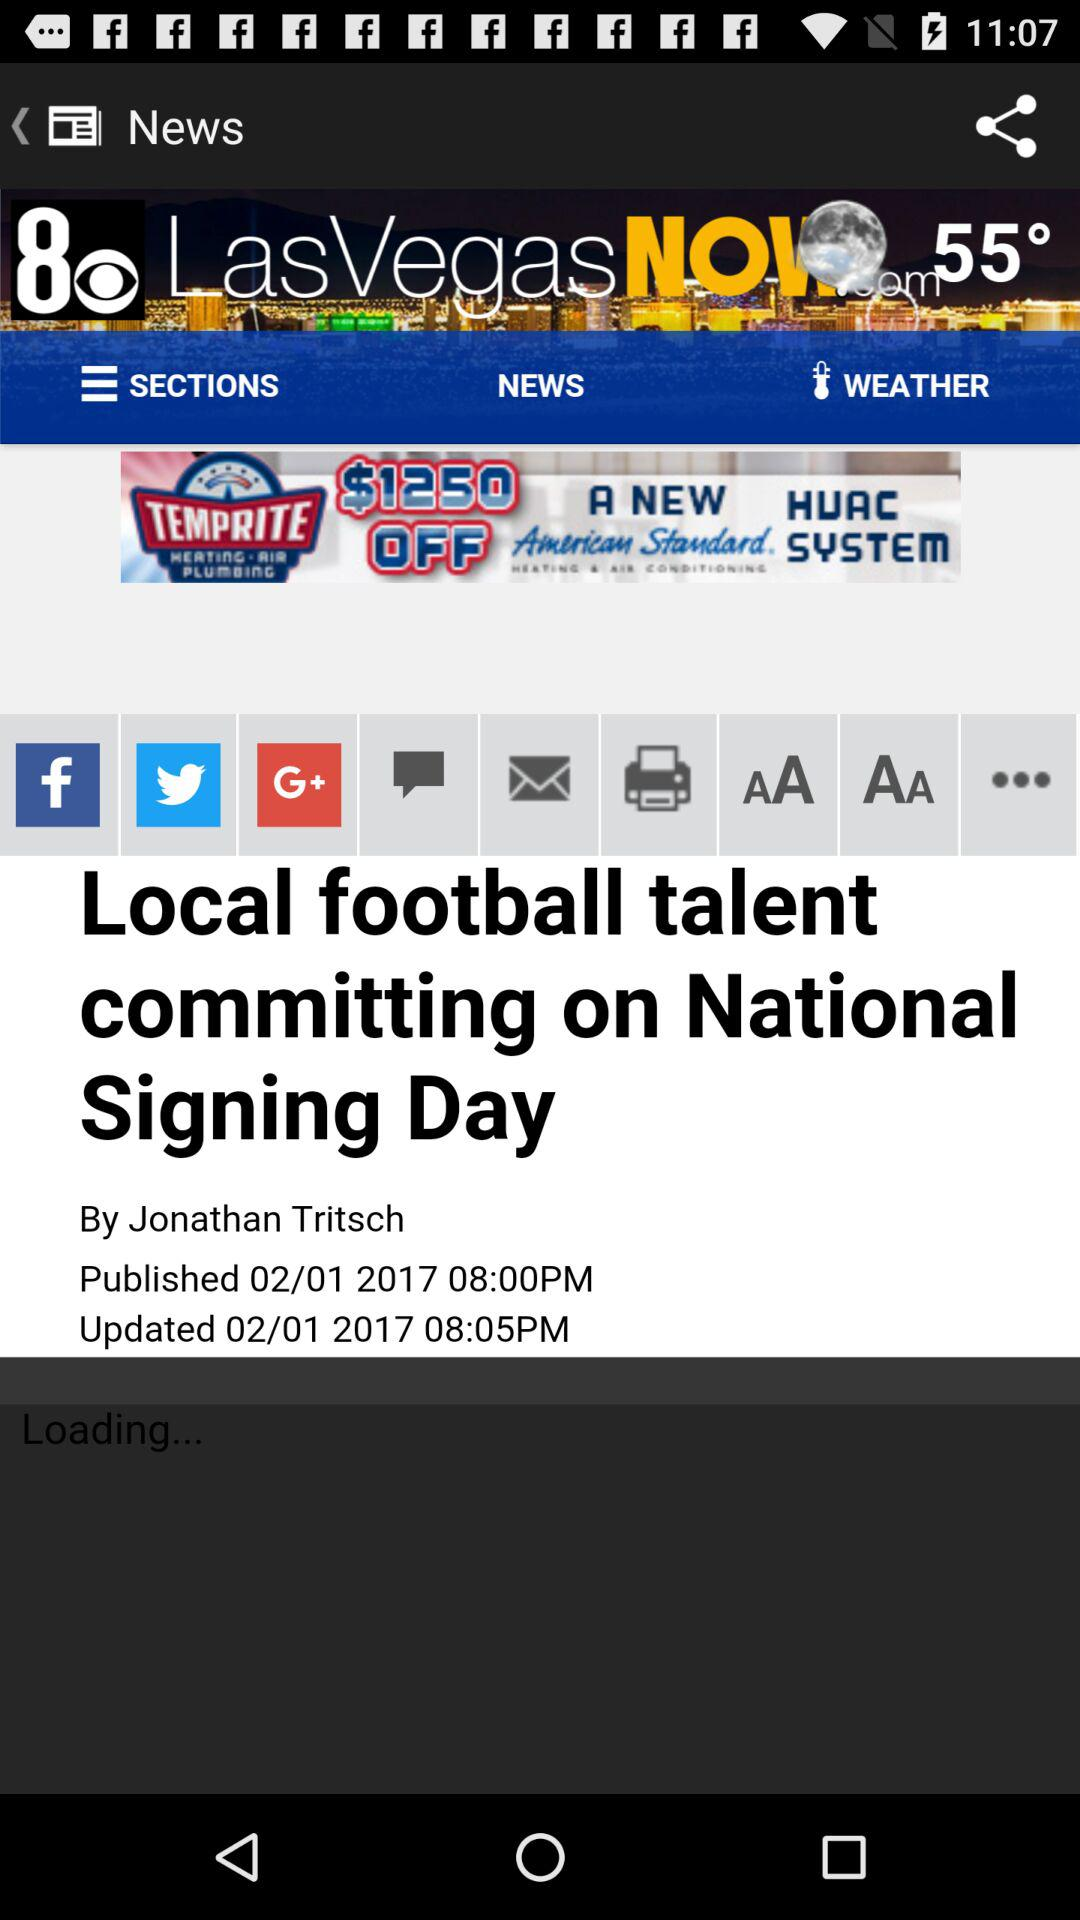When was it published? It was published on February 01, 2017. 